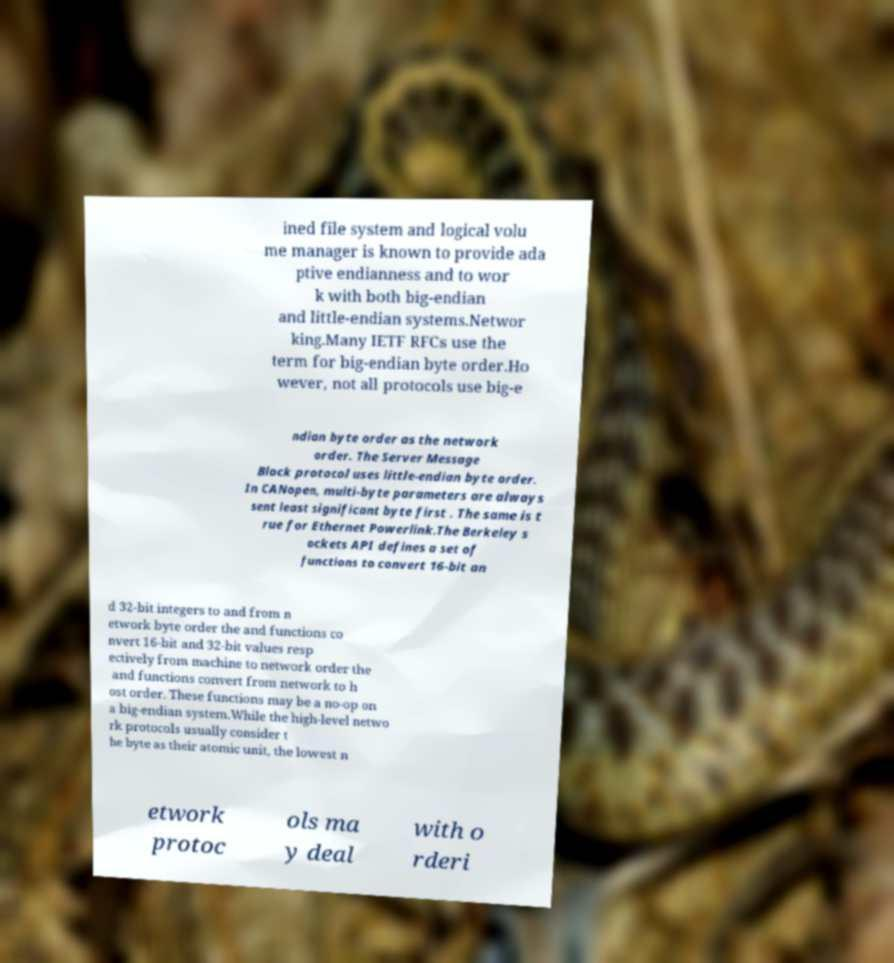Please identify and transcribe the text found in this image. ined file system and logical volu me manager is known to provide ada ptive endianness and to wor k with both big-endian and little-endian systems.Networ king.Many IETF RFCs use the term for big-endian byte order.Ho wever, not all protocols use big-e ndian byte order as the network order. The Server Message Block protocol uses little-endian byte order. In CANopen, multi-byte parameters are always sent least significant byte first . The same is t rue for Ethernet Powerlink.The Berkeley s ockets API defines a set of functions to convert 16-bit an d 32-bit integers to and from n etwork byte order the and functions co nvert 16-bit and 32-bit values resp ectively from machine to network order the and functions convert from network to h ost order. These functions may be a no-op on a big-endian system.While the high-level netwo rk protocols usually consider t he byte as their atomic unit, the lowest n etwork protoc ols ma y deal with o rderi 